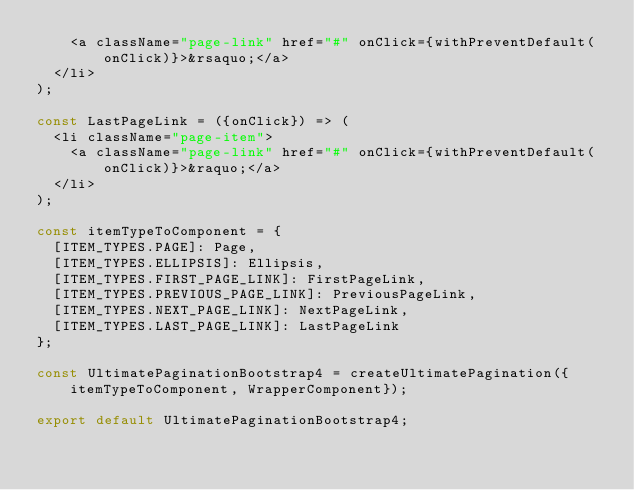<code> <loc_0><loc_0><loc_500><loc_500><_JavaScript_>    <a className="page-link" href="#" onClick={withPreventDefault(onClick)}>&rsaquo;</a>
  </li>
);

const LastPageLink = ({onClick}) => (
  <li className="page-item">
    <a className="page-link" href="#" onClick={withPreventDefault(onClick)}>&raquo;</a>
  </li>
);

const itemTypeToComponent = {
  [ITEM_TYPES.PAGE]: Page,
  [ITEM_TYPES.ELLIPSIS]: Ellipsis,
  [ITEM_TYPES.FIRST_PAGE_LINK]: FirstPageLink,
  [ITEM_TYPES.PREVIOUS_PAGE_LINK]: PreviousPageLink,
  [ITEM_TYPES.NEXT_PAGE_LINK]: NextPageLink,
  [ITEM_TYPES.LAST_PAGE_LINK]: LastPageLink
};

const UltimatePaginationBootstrap4 = createUltimatePagination({itemTypeToComponent, WrapperComponent});

export default UltimatePaginationBootstrap4;
</code> 